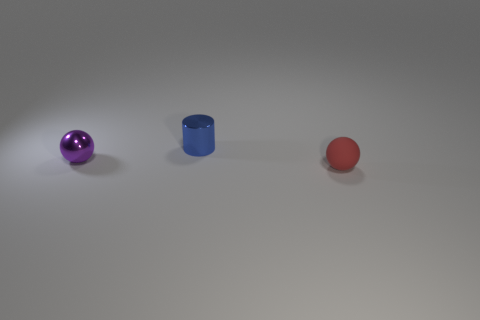Is the number of large yellow balls greater than the number of tiny red objects?
Give a very brief answer. No. What is the tiny red thing made of?
Offer a very short reply. Rubber. The tiny rubber object that is in front of the small cylinder is what color?
Your answer should be compact. Red. Is the number of small blue shiny things that are in front of the small red rubber ball greater than the number of small blue metal objects that are on the left side of the small purple sphere?
Keep it short and to the point. No. What size is the sphere that is on the left side of the tiny rubber thing in front of the tiny shiny object that is behind the small metallic ball?
Provide a short and direct response. Small. Is there a object of the same color as the metallic ball?
Provide a short and direct response. No. How many blue metal objects are there?
Your answer should be very brief. 1. What is the material of the tiny ball that is on the right side of the small metallic thing behind the small sphere on the left side of the red matte object?
Ensure brevity in your answer.  Rubber. Are there any other purple things made of the same material as the purple object?
Ensure brevity in your answer.  No. Do the blue cylinder and the tiny purple sphere have the same material?
Offer a terse response. Yes. 